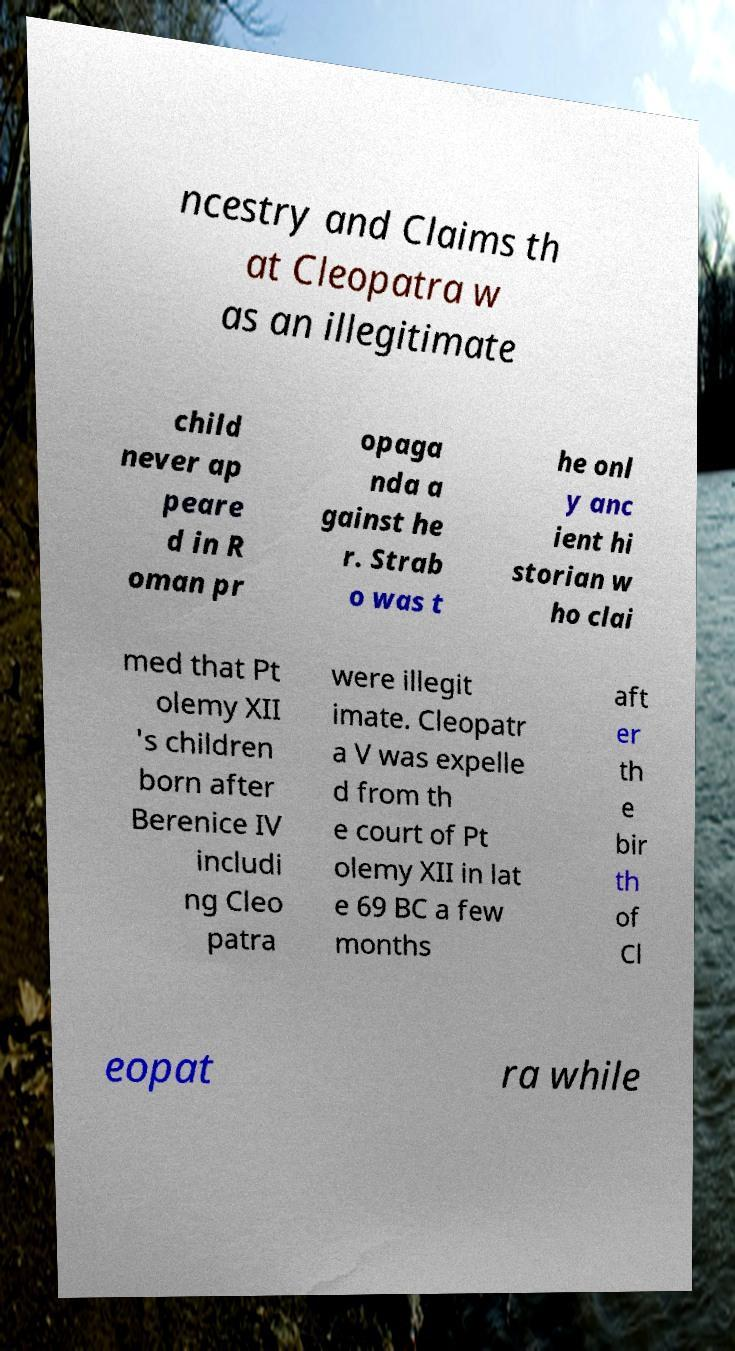Could you extract and type out the text from this image? ncestry and Claims th at Cleopatra w as an illegitimate child never ap peare d in R oman pr opaga nda a gainst he r. Strab o was t he onl y anc ient hi storian w ho clai med that Pt olemy XII 's children born after Berenice IV includi ng Cleo patra were illegit imate. Cleopatr a V was expelle d from th e court of Pt olemy XII in lat e 69 BC a few months aft er th e bir th of Cl eopat ra while 